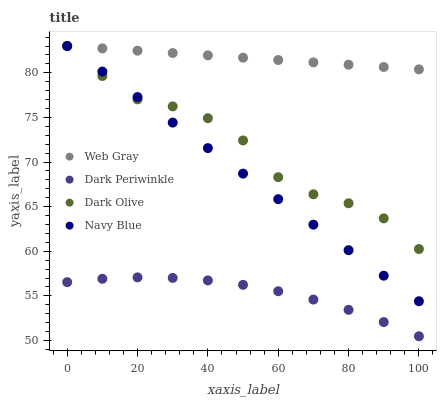Does Dark Periwinkle have the minimum area under the curve?
Answer yes or no. Yes. Does Web Gray have the maximum area under the curve?
Answer yes or no. Yes. Does Navy Blue have the minimum area under the curve?
Answer yes or no. No. Does Navy Blue have the maximum area under the curve?
Answer yes or no. No. Is Web Gray the smoothest?
Answer yes or no. Yes. Is Dark Olive the roughest?
Answer yes or no. Yes. Is Navy Blue the smoothest?
Answer yes or no. No. Is Navy Blue the roughest?
Answer yes or no. No. Does Dark Periwinkle have the lowest value?
Answer yes or no. Yes. Does Navy Blue have the lowest value?
Answer yes or no. No. Does Web Gray have the highest value?
Answer yes or no. Yes. Does Dark Periwinkle have the highest value?
Answer yes or no. No. Is Dark Periwinkle less than Web Gray?
Answer yes or no. Yes. Is Web Gray greater than Dark Periwinkle?
Answer yes or no. Yes. Does Dark Olive intersect Web Gray?
Answer yes or no. Yes. Is Dark Olive less than Web Gray?
Answer yes or no. No. Is Dark Olive greater than Web Gray?
Answer yes or no. No. Does Dark Periwinkle intersect Web Gray?
Answer yes or no. No. 